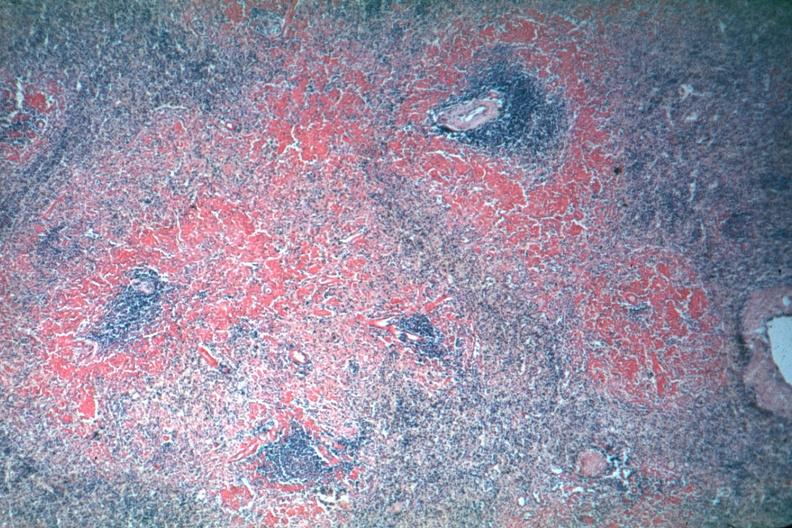what is not the best?
Answer the question using a single word or phrase. Exposure 